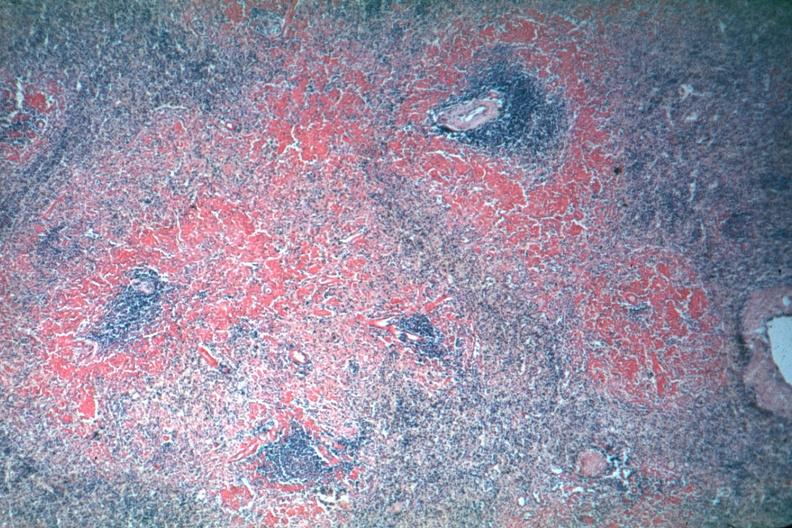what is not the best?
Answer the question using a single word or phrase. Exposure 